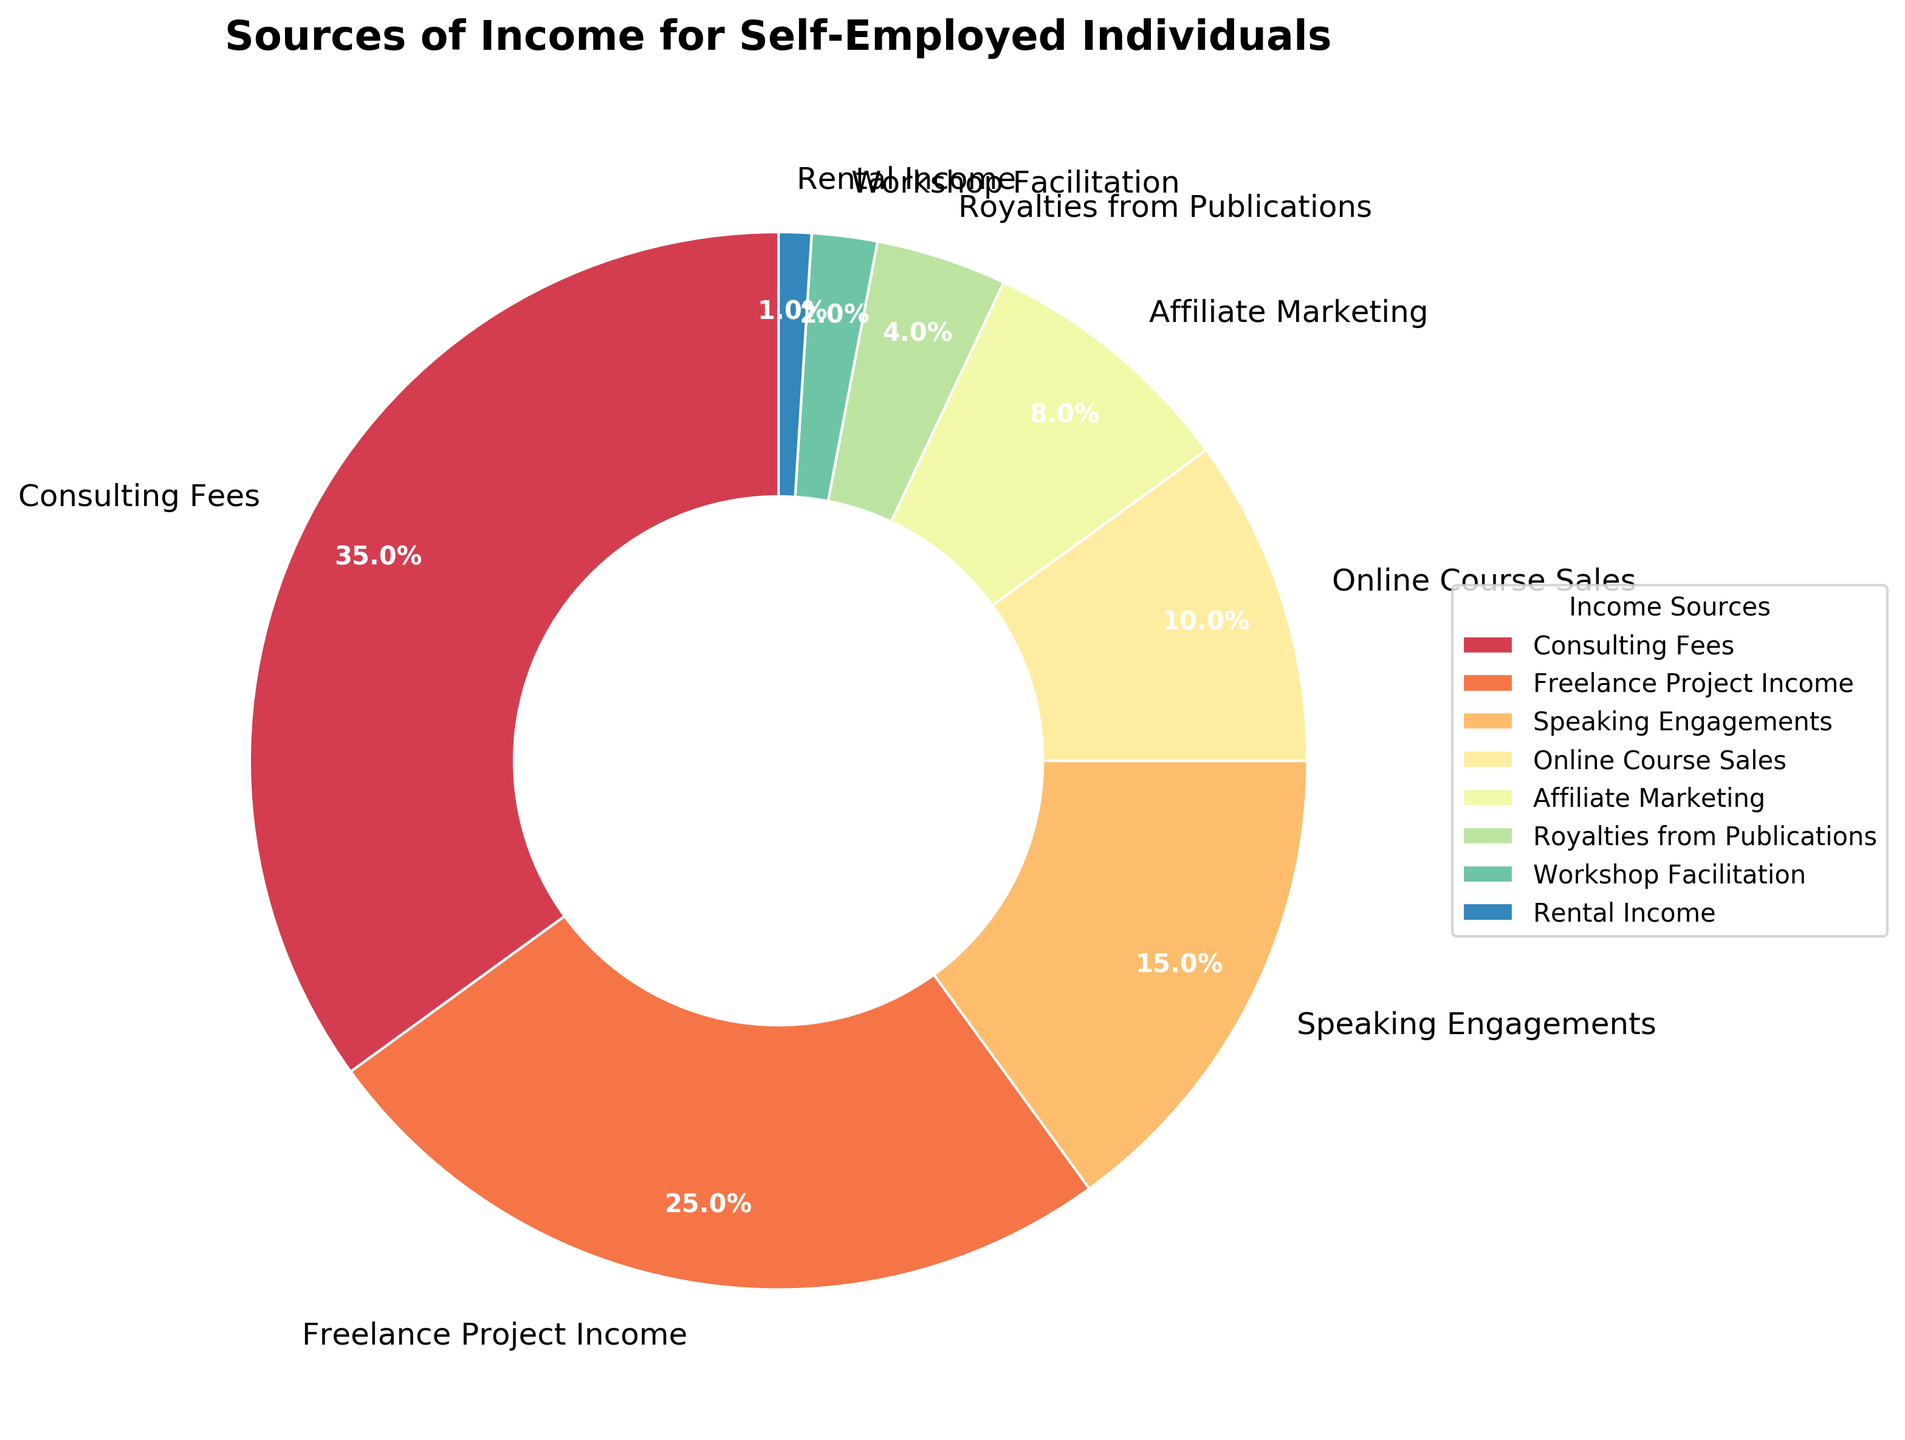What's the largest source of income? Examine the pie chart and identify the segment with the highest percentage. Consulting Fees constitute the largest section at 35%.
Answer: Consulting Fees What's the combined income percentage from Speaking Engagements and Online Course Sales? Add the percentages of Speaking Engagements (15%) and Online Course Sales (10%). The total is 15% + 10% = 25%.
Answer: 25% Which income source is smaller, Affiliate Marketing or Royalties from Publications? Compare the percentages of the two sources. Affiliate Marketing has 8%, whereas Royalties from Publications have 4%. Therefore, Royalties from Publications is smaller.
Answer: Royalties from Publications How does Workshop Facilitation's income percentage compare to Rental Income? Compare the two percentages visually. Workshop Facilitation contributes 2%, while Rental Income contributes 1%. Workshop Facilitation's percentage is higher by 1%.
Answer: Workshop Facilitation is higher What's the sum of income percentages from Freelance Project Income, Online Course Sales, and Affiliate Marketing? Add the percentages: Freelance Project Income (25%) + Online Course Sales (10%) + Affiliate Marketing (8%). The sum is 25% + 10% + 8% = 43%.
Answer: 43% Which source of income has the smallest percentage, and what is that percentage? Examine the pie chart and locate the smallest segment. Rental Income has the smallest percentage at 1%.
Answer: Rental Income, 1% Which income sources together make up at least half the total income? Identify and sum sources from the highest until achieving at least 50%. Consulting Fees (35%) + Freelance Project Income (25%) = 60% ≥ 50%. These two sources alone exceed halfway.
Answer: Consulting Fees and Freelance Project Income How much larger is the percentage of Consulting Fees compared to Affiliate Marketing? Subtract the percentage of Affiliate Marketing from Consulting Fees: 35% - 8% = 27%.
Answer: 27% What is the average percentage of the smallest three income sources? Identify the smallest three sources: Rental Income (1%), Workshop Facilitation (2%), Royalties from Publications (4%). Average = (1% + 2% + 4%) / 3 = 7% / 3 ≈ 2.33%.
Answer: ~2.33% Which income source's percentage is closest to 10%? Visually identify the source segment closest to 10%. Online Course Sales exactly contribute 10%.
Answer: Online Course Sales 